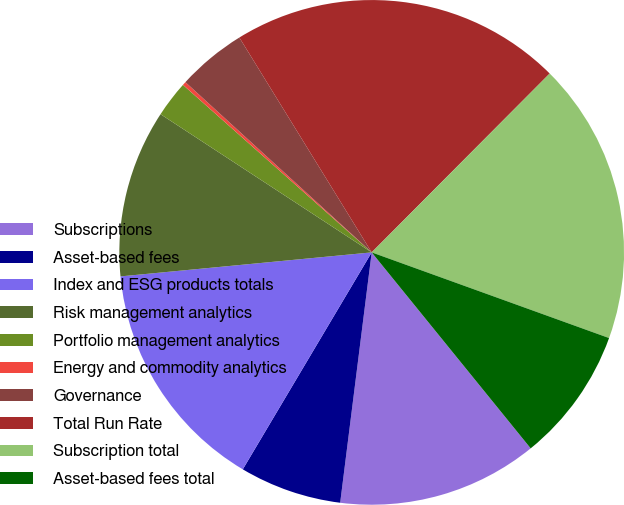Convert chart to OTSL. <chart><loc_0><loc_0><loc_500><loc_500><pie_chart><fcel>Subscriptions<fcel>Asset-based fees<fcel>Index and ESG products totals<fcel>Risk management analytics<fcel>Portfolio management analytics<fcel>Energy and commodity analytics<fcel>Governance<fcel>Total Run Rate<fcel>Subscription total<fcel>Asset-based fees total<nl><fcel>12.84%<fcel>6.54%<fcel>14.95%<fcel>10.74%<fcel>2.33%<fcel>0.23%<fcel>4.43%<fcel>21.25%<fcel>18.05%<fcel>8.64%<nl></chart> 